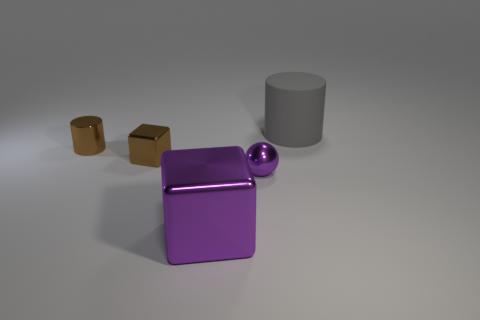What is the material of the large object that is in front of the small brown shiny cylinder?
Offer a terse response. Metal. Does the cylinder to the right of the tiny brown shiny cylinder have the same size as the metallic thing behind the brown metallic block?
Provide a succinct answer. No. What is the color of the tiny cylinder?
Your answer should be compact. Brown. Does the small shiny thing that is to the right of the purple metal block have the same shape as the gray thing?
Ensure brevity in your answer.  No. What is the material of the tiny brown cube?
Offer a terse response. Metal. What is the shape of the thing that is the same size as the purple metallic block?
Your answer should be compact. Cylinder. Are there any tiny rubber things that have the same color as the sphere?
Keep it short and to the point. No. Do the tiny metal cylinder and the large thing that is in front of the small cylinder have the same color?
Offer a terse response. No. The cylinder that is on the right side of the brown object on the right side of the small brown metallic cylinder is what color?
Your answer should be compact. Gray. Is there a purple metal cube to the right of the big object that is on the left side of the big object that is behind the metallic cylinder?
Give a very brief answer. No. 